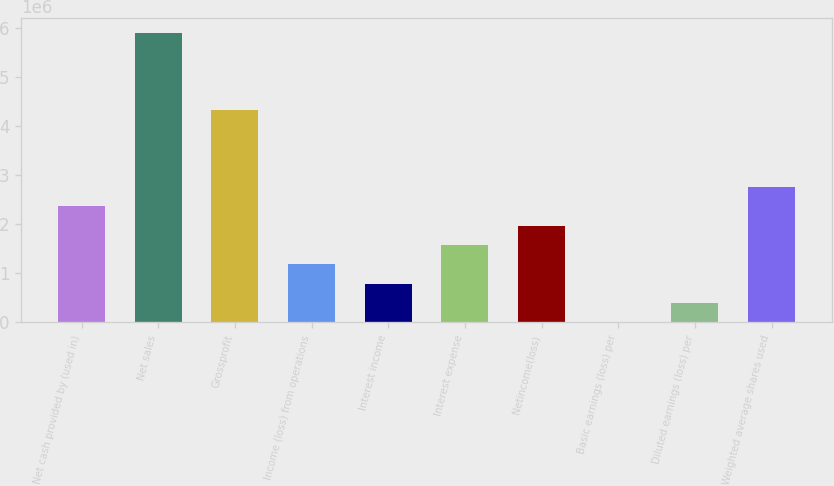<chart> <loc_0><loc_0><loc_500><loc_500><bar_chart><fcel>Net cash provided by (used in)<fcel>Net sales<fcel>Grossprofit<fcel>Income (loss) from operations<fcel>Interest income<fcel>Interest expense<fcel>Netincome(loss)<fcel>Basic earnings (loss) per<fcel>Diluted earnings (loss) per<fcel>Weighted average shares used<nl><fcel>2.35976e+06<fcel>5.8994e+06<fcel>4.32623e+06<fcel>1.17988e+06<fcel>786588<fcel>1.57317e+06<fcel>1.96647e+06<fcel>0.39<fcel>393294<fcel>2.75306e+06<nl></chart> 